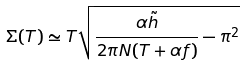<formula> <loc_0><loc_0><loc_500><loc_500>\Sigma ( T ) \simeq T \sqrt { \frac { \alpha \tilde { h } } { 2 \pi N ( T + \alpha f ) } - \pi ^ { 2 } }</formula> 